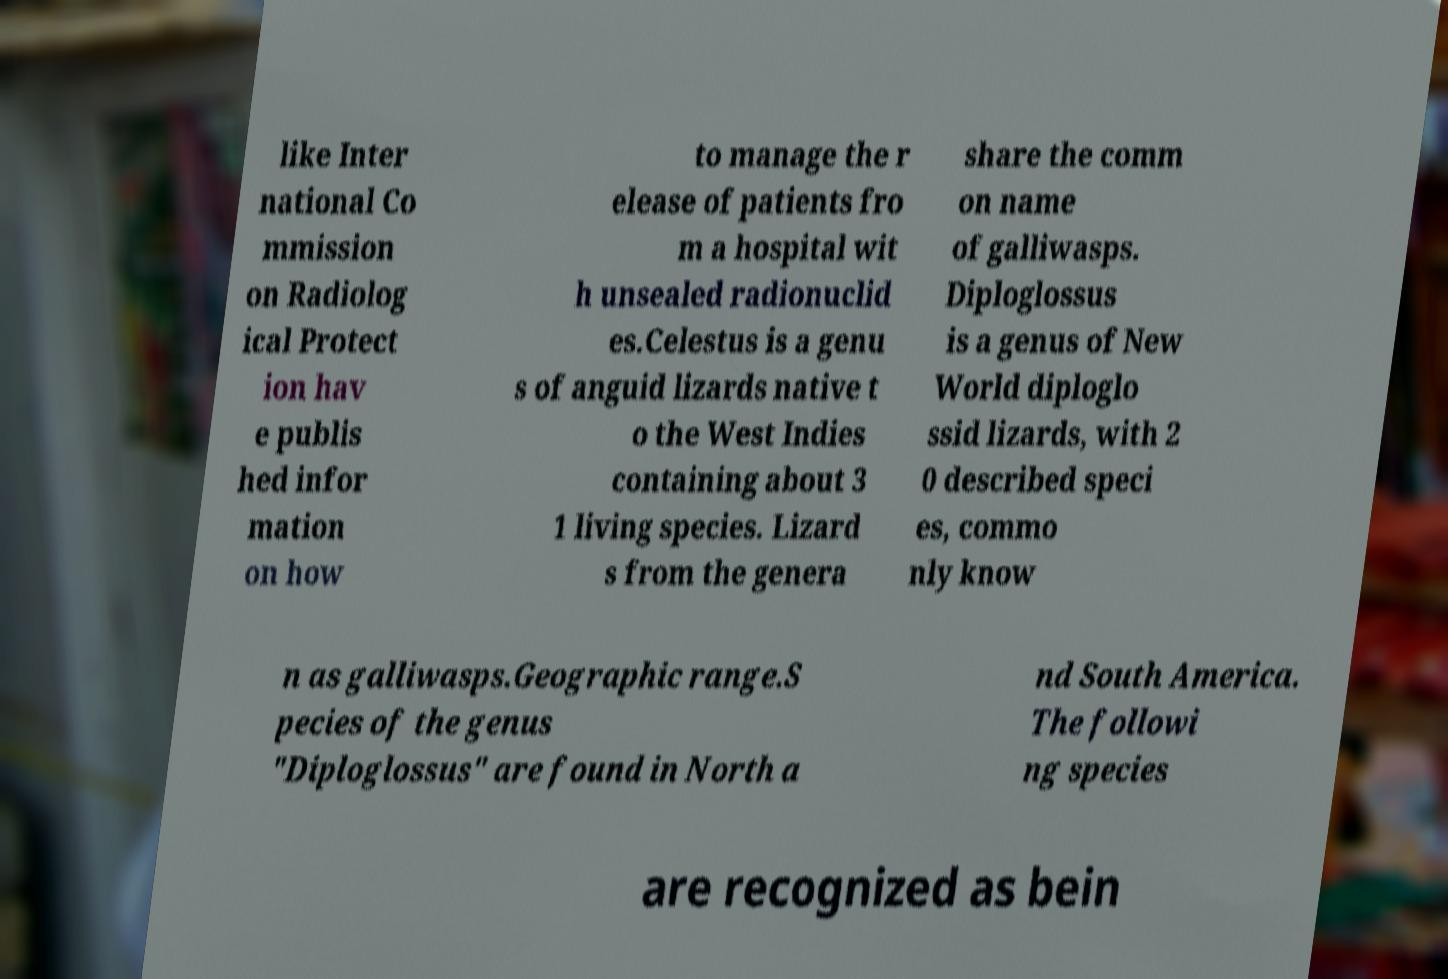I need the written content from this picture converted into text. Can you do that? like Inter national Co mmission on Radiolog ical Protect ion hav e publis hed infor mation on how to manage the r elease of patients fro m a hospital wit h unsealed radionuclid es.Celestus is a genu s of anguid lizards native t o the West Indies containing about 3 1 living species. Lizard s from the genera share the comm on name of galliwasps. Diploglossus is a genus of New World diploglo ssid lizards, with 2 0 described speci es, commo nly know n as galliwasps.Geographic range.S pecies of the genus "Diploglossus" are found in North a nd South America. The followi ng species are recognized as bein 